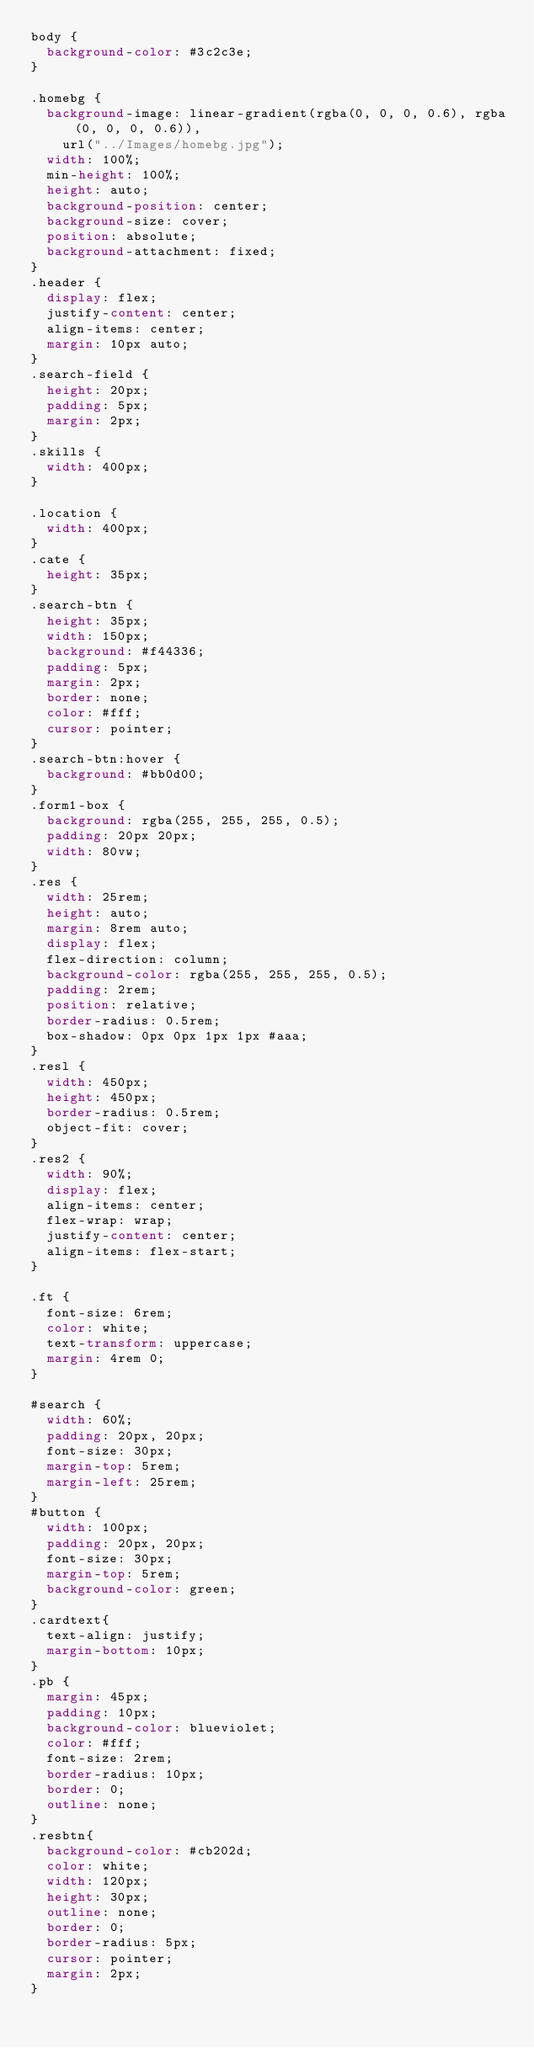<code> <loc_0><loc_0><loc_500><loc_500><_CSS_>body {
  background-color: #3c2c3e;
}

.homebg {
  background-image: linear-gradient(rgba(0, 0, 0, 0.6), rgba(0, 0, 0, 0.6)),
    url("../Images/homebg.jpg");
  width: 100%;
  min-height: 100%;
  height: auto;
  background-position: center;
  background-size: cover;
  position: absolute;
  background-attachment: fixed;
}
.header {
  display: flex;
  justify-content: center;
  align-items: center;
  margin: 10px auto;
}
.search-field {
  height: 20px;
  padding: 5px;
  margin: 2px;
}
.skills {
  width: 400px;
}

.location {
  width: 400px;
}
.cate {
  height: 35px;
}
.search-btn {
  height: 35px;
  width: 150px;
  background: #f44336;
  padding: 5px;
  margin: 2px;
  border: none;
  color: #fff;
  cursor: pointer;
}
.search-btn:hover {
  background: #bb0d00;
}
.form1-box {
  background: rgba(255, 255, 255, 0.5);
  padding: 20px 20px;
  width: 80vw;
}
.res {
  width: 25rem;
  height: auto;
  margin: 8rem auto;
  display: flex;
  flex-direction: column;
  background-color: rgba(255, 255, 255, 0.5);
  padding: 2rem;
  position: relative;
  border-radius: 0.5rem;
  box-shadow: 0px 0px 1px 1px #aaa;
}
.resl {
  width: 450px;
  height: 450px;
  border-radius: 0.5rem;
  object-fit: cover;
}
.res2 {
  width: 90%;
  display: flex;
  align-items: center;
  flex-wrap: wrap;
  justify-content: center;
  align-items: flex-start;
}

.ft {
  font-size: 6rem;
  color: white;
  text-transform: uppercase;
  margin: 4rem 0;
}

#search {
  width: 60%;
  padding: 20px, 20px;
  font-size: 30px;
  margin-top: 5rem;
  margin-left: 25rem;
}
#button {
  width: 100px;
  padding: 20px, 20px;
  font-size: 30px;
  margin-top: 5rem;
  background-color: green;
}
.cardtext{
  text-align: justify;
  margin-bottom: 10px;
}
.pb {
  margin: 45px;
  padding: 10px;
  background-color: blueviolet;
  color: #fff;
  font-size: 2rem;
  border-radius: 10px;
  border: 0;
  outline: none;
}
.resbtn{
  background-color: #cb202d;
  color: white;
  width: 120px;
  height: 30px;
  outline: none;
  border: 0;
  border-radius: 5px;
  cursor: pointer;
  margin: 2px;
}
</code> 